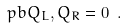Convert formula to latex. <formula><loc_0><loc_0><loc_500><loc_500>\ p b { Q _ { L } , Q _ { R } } = 0 \ .</formula> 